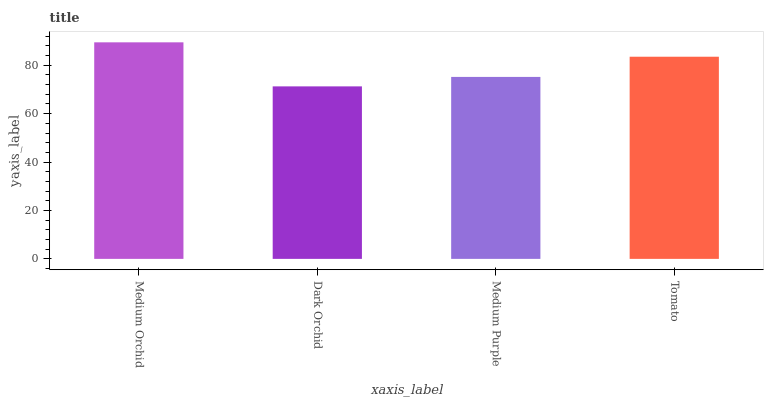Is Dark Orchid the minimum?
Answer yes or no. Yes. Is Medium Orchid the maximum?
Answer yes or no. Yes. Is Medium Purple the minimum?
Answer yes or no. No. Is Medium Purple the maximum?
Answer yes or no. No. Is Medium Purple greater than Dark Orchid?
Answer yes or no. Yes. Is Dark Orchid less than Medium Purple?
Answer yes or no. Yes. Is Dark Orchid greater than Medium Purple?
Answer yes or no. No. Is Medium Purple less than Dark Orchid?
Answer yes or no. No. Is Tomato the high median?
Answer yes or no. Yes. Is Medium Purple the low median?
Answer yes or no. Yes. Is Medium Orchid the high median?
Answer yes or no. No. Is Tomato the low median?
Answer yes or no. No. 